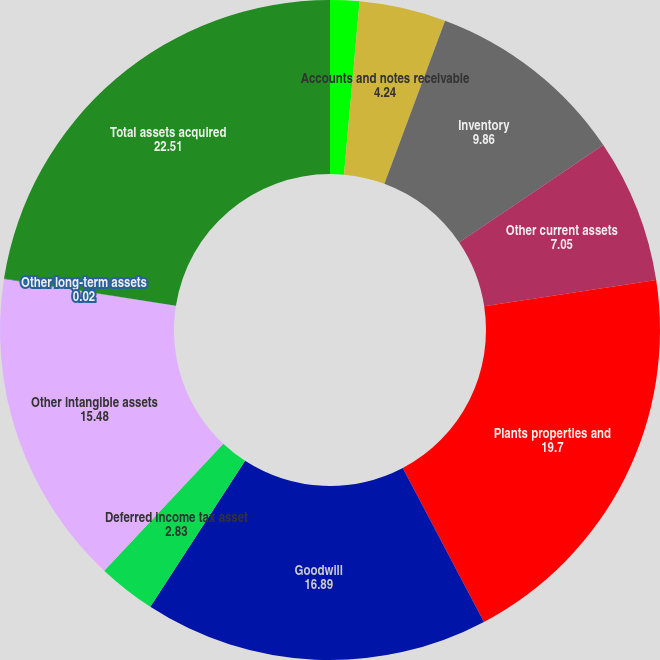<chart> <loc_0><loc_0><loc_500><loc_500><pie_chart><fcel>Cash and temporary investments<fcel>Accounts and notes receivable<fcel>Inventory<fcel>Other current assets<fcel>Plants properties and<fcel>Goodwill<fcel>Deferred income tax asset<fcel>Other intangible assets<fcel>Other long-term assets<fcel>Total assets acquired<nl><fcel>1.43%<fcel>4.24%<fcel>9.86%<fcel>7.05%<fcel>19.7%<fcel>16.89%<fcel>2.83%<fcel>15.48%<fcel>0.02%<fcel>22.51%<nl></chart> 